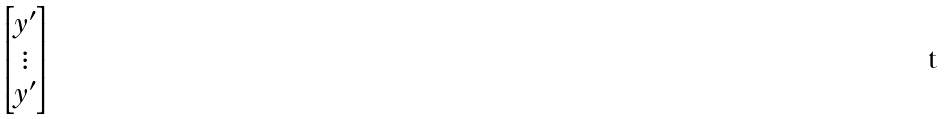Convert formula to latex. <formula><loc_0><loc_0><loc_500><loc_500>\begin{bmatrix} y ^ { \prime } \\ \vdots \\ y ^ { \prime } \end{bmatrix}</formula> 